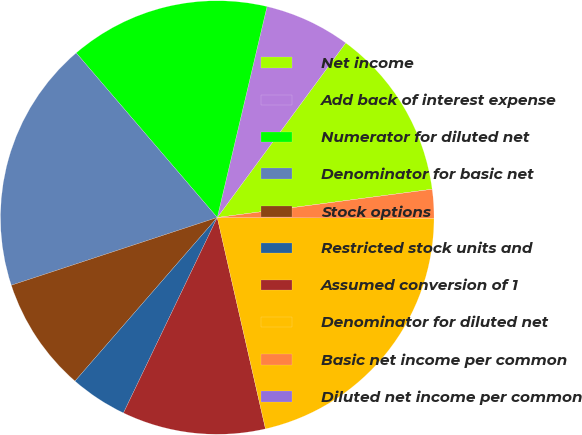Convert chart. <chart><loc_0><loc_0><loc_500><loc_500><pie_chart><fcel>Net income<fcel>Add back of interest expense<fcel>Numerator for diluted net<fcel>Denominator for basic net<fcel>Stock options<fcel>Restricted stock units and<fcel>Assumed conversion of 1<fcel>Denominator for diluted net<fcel>Basic net income per common<fcel>Diluted net income per common<nl><fcel>12.82%<fcel>6.41%<fcel>14.96%<fcel>18.78%<fcel>8.55%<fcel>4.27%<fcel>10.69%<fcel>21.37%<fcel>2.14%<fcel>0.0%<nl></chart> 